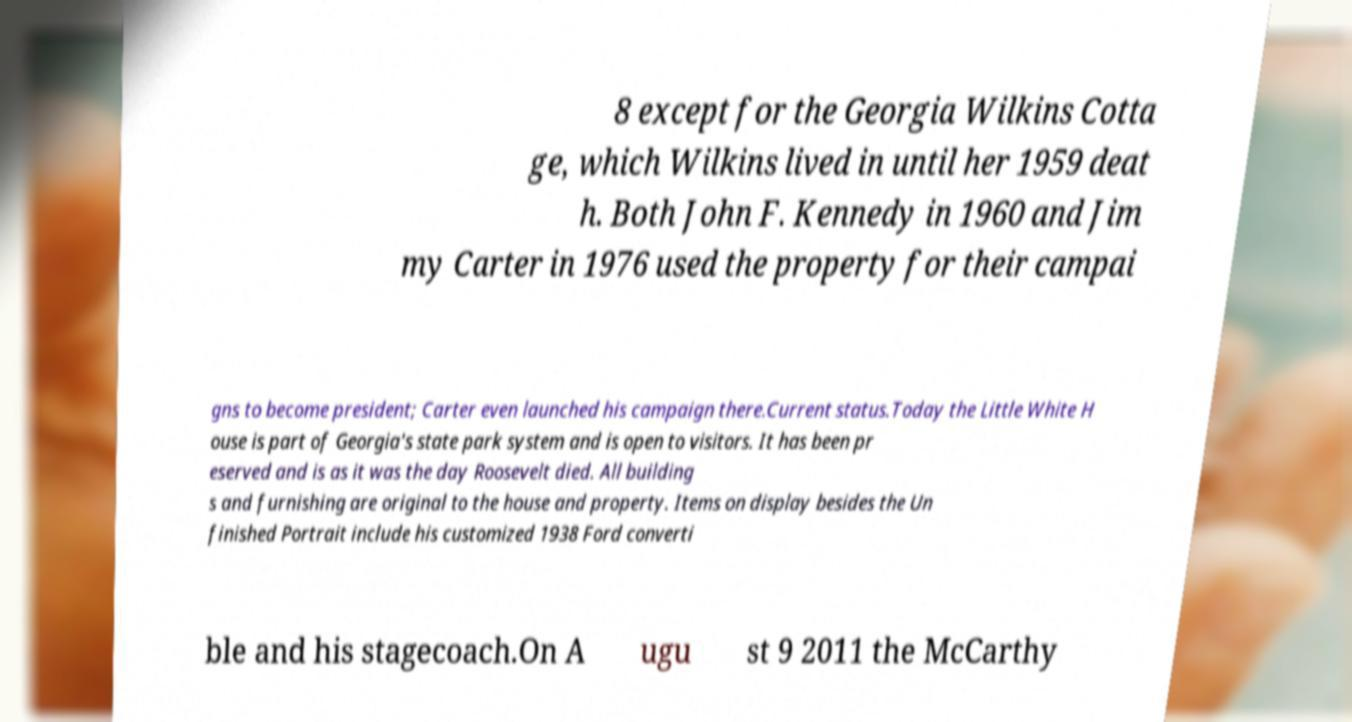Could you extract and type out the text from this image? 8 except for the Georgia Wilkins Cotta ge, which Wilkins lived in until her 1959 deat h. Both John F. Kennedy in 1960 and Jim my Carter in 1976 used the property for their campai gns to become president; Carter even launched his campaign there.Current status.Today the Little White H ouse is part of Georgia's state park system and is open to visitors. It has been pr eserved and is as it was the day Roosevelt died. All building s and furnishing are original to the house and property. Items on display besides the Un finished Portrait include his customized 1938 Ford converti ble and his stagecoach.On A ugu st 9 2011 the McCarthy 